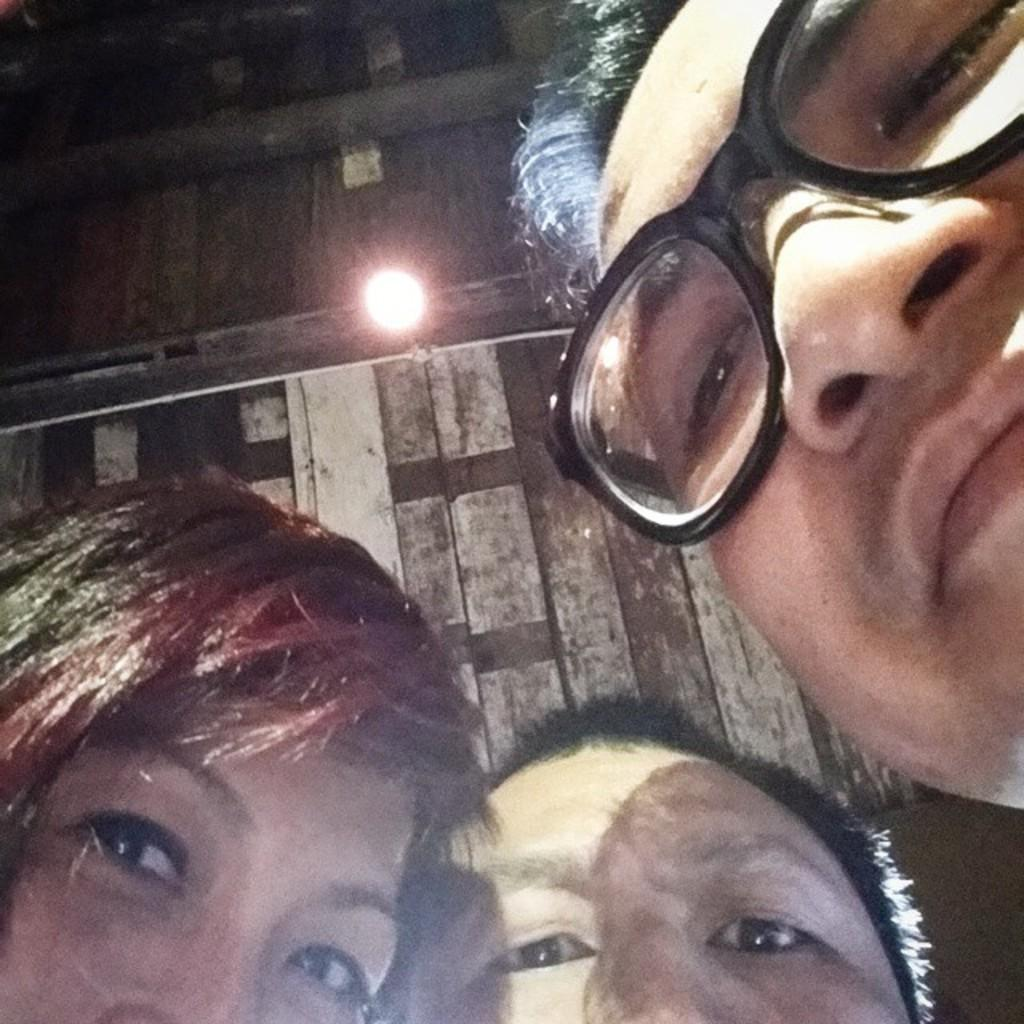How many people are present in the image? There are three people in the image. What is located on the wall in the image? There is an electric light on the wall in the image. What type of angle is being used by the people in the image? There is no specific angle being used by the people in the image; they are simply standing or positioned in the image. What type of cast is visible on any of the people in the image? There is no cast visible on any of the people in the image. What type of slip is being worn by any of the people in the image? There is no slip visible on any of the people in the image. 